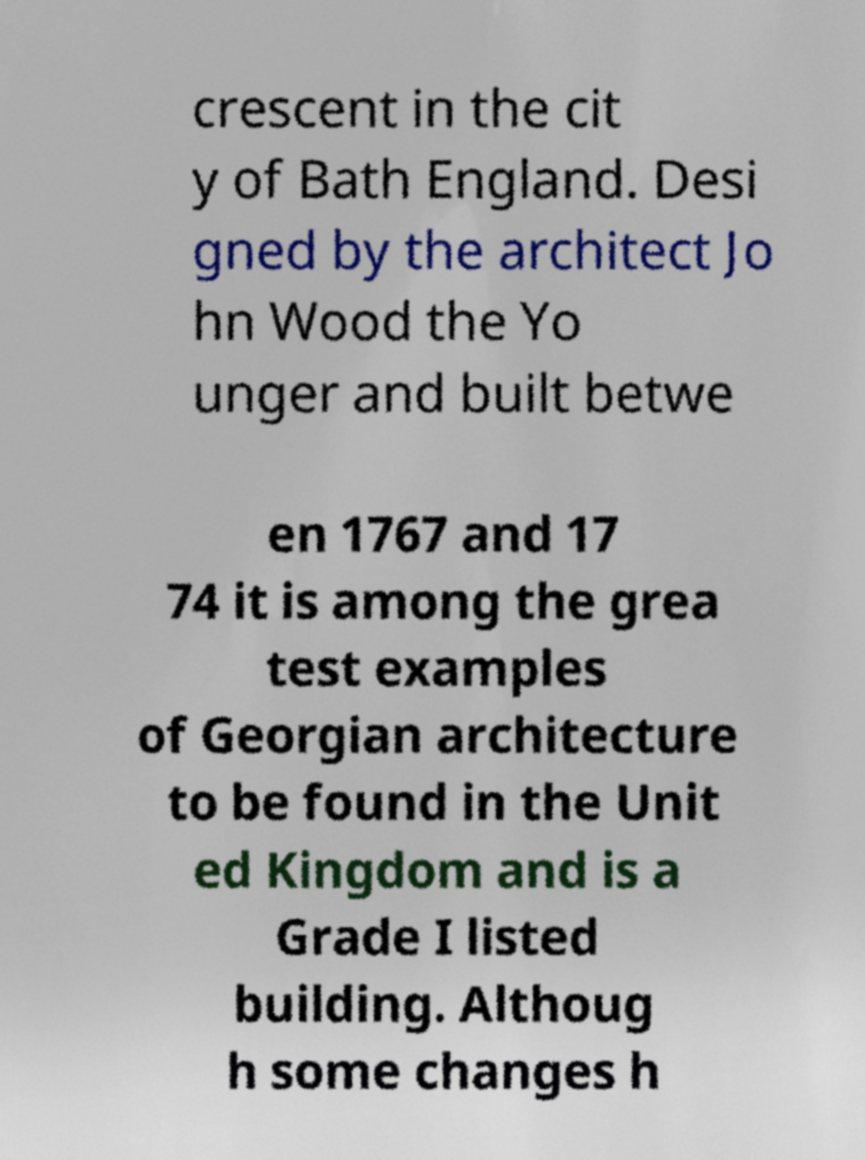Could you assist in decoding the text presented in this image and type it out clearly? crescent in the cit y of Bath England. Desi gned by the architect Jo hn Wood the Yo unger and built betwe en 1767 and 17 74 it is among the grea test examples of Georgian architecture to be found in the Unit ed Kingdom and is a Grade I listed building. Althoug h some changes h 